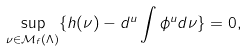Convert formula to latex. <formula><loc_0><loc_0><loc_500><loc_500>\sup _ { \nu \in \mathcal { M } _ { f } ( \Lambda ) } \{ h ( \nu ) - d ^ { u } \int \phi ^ { u } d \nu \} = 0 ,</formula> 